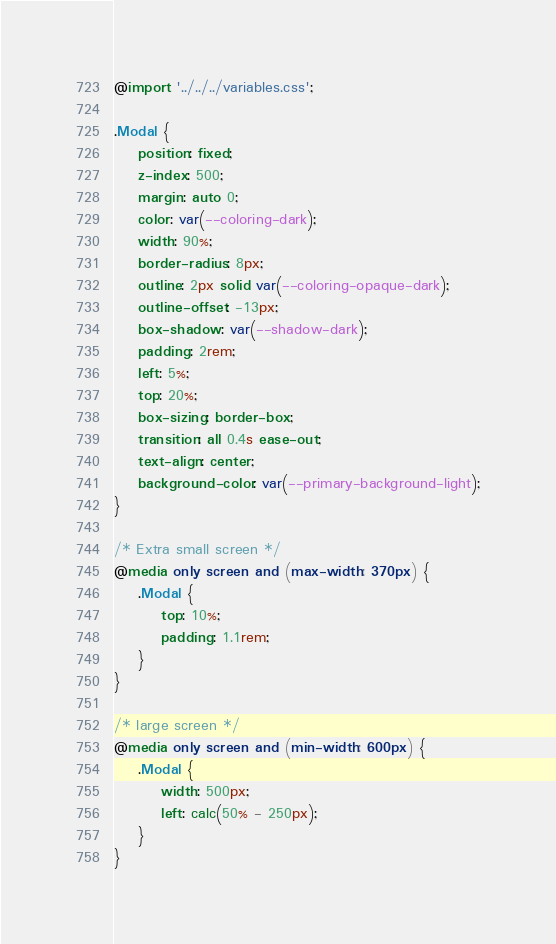Convert code to text. <code><loc_0><loc_0><loc_500><loc_500><_CSS_>@import '../../../variables.css';

.Modal {
    position: fixed;
    z-index: 500;
    margin: auto 0;
    color: var(--coloring-dark);
    width: 90%;
    border-radius: 8px;
    outline: 2px solid var(--coloring-opaque-dark);
    outline-offset: -13px;
    box-shadow: var(--shadow-dark);
    padding: 2rem;
    left: 5%;
    top: 20%;
    box-sizing: border-box;
    transition: all 0.4s ease-out;
    text-align: center;
    background-color: var(--primary-background-light);
}

/* Extra small screen */
@media only screen and (max-width: 370px) {
    .Modal {
        top: 10%;
        padding: 1.1rem;
    }
}

/* large screen */
@media only screen and (min-width: 600px) {
    .Modal {
        width: 500px;
        left: calc(50% - 250px);
    }
}</code> 